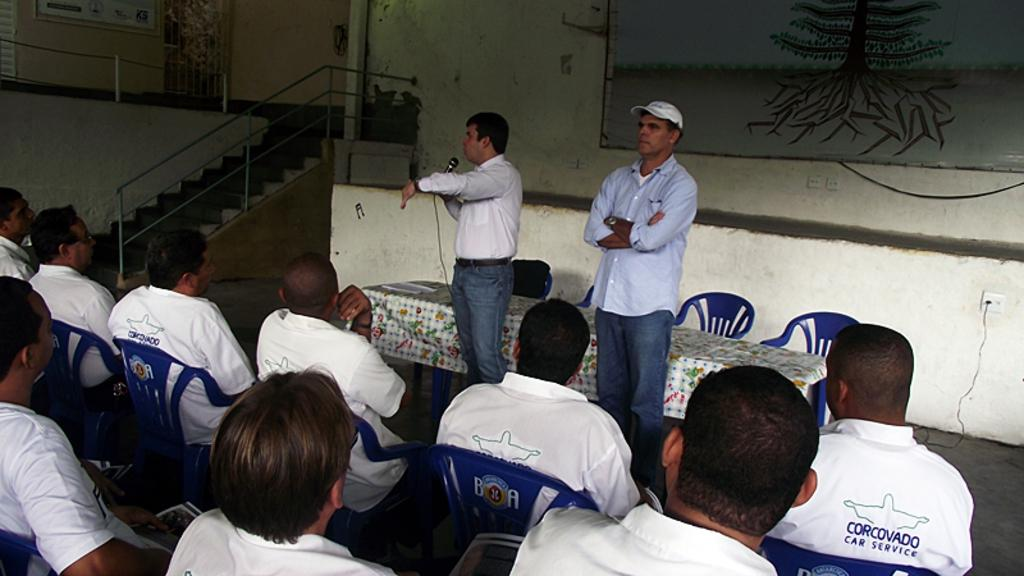<image>
Offer a succinct explanation of the picture presented. The men in the audience are from Corcovado Car Service. 